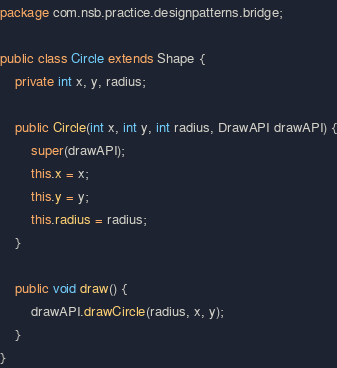Convert code to text. <code><loc_0><loc_0><loc_500><loc_500><_Java_>package com.nsb.practice.designpatterns.bridge;

public class Circle extends Shape {
    private int x, y, radius;

    public Circle(int x, int y, int radius, DrawAPI drawAPI) {
        super(drawAPI);
        this.x = x;
        this.y = y;
        this.radius = radius;
    }

    public void draw() {
        drawAPI.drawCircle(radius, x, y);
    }
}
</code> 